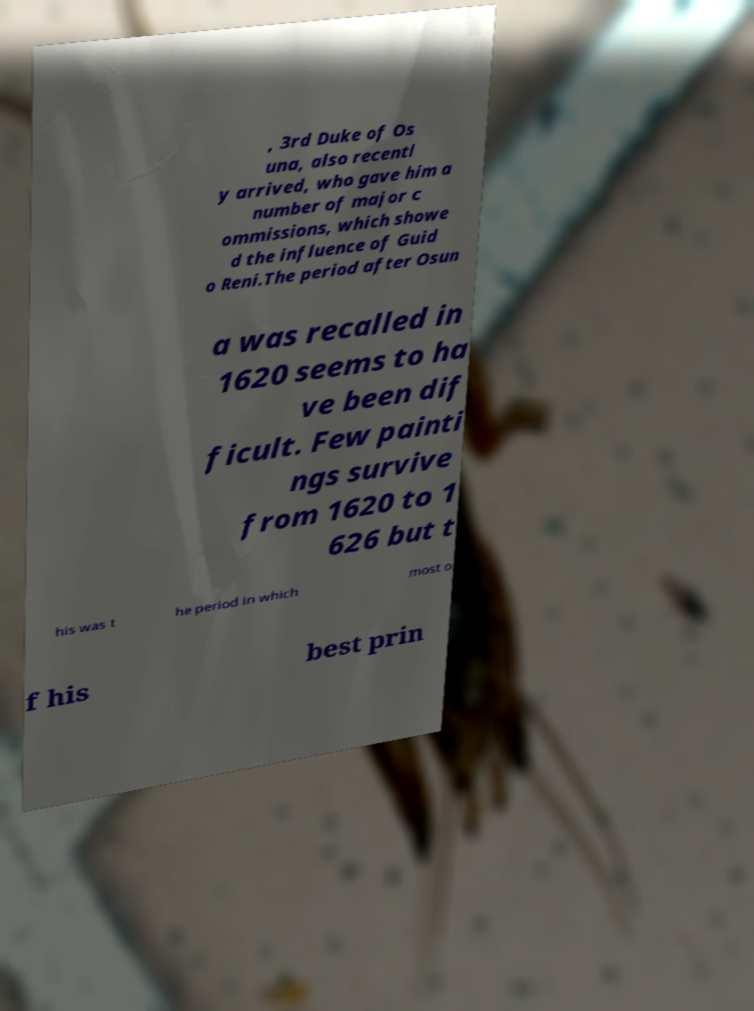There's text embedded in this image that I need extracted. Can you transcribe it verbatim? , 3rd Duke of Os una, also recentl y arrived, who gave him a number of major c ommissions, which showe d the influence of Guid o Reni.The period after Osun a was recalled in 1620 seems to ha ve been dif ficult. Few painti ngs survive from 1620 to 1 626 but t his was t he period in which most o f his best prin 